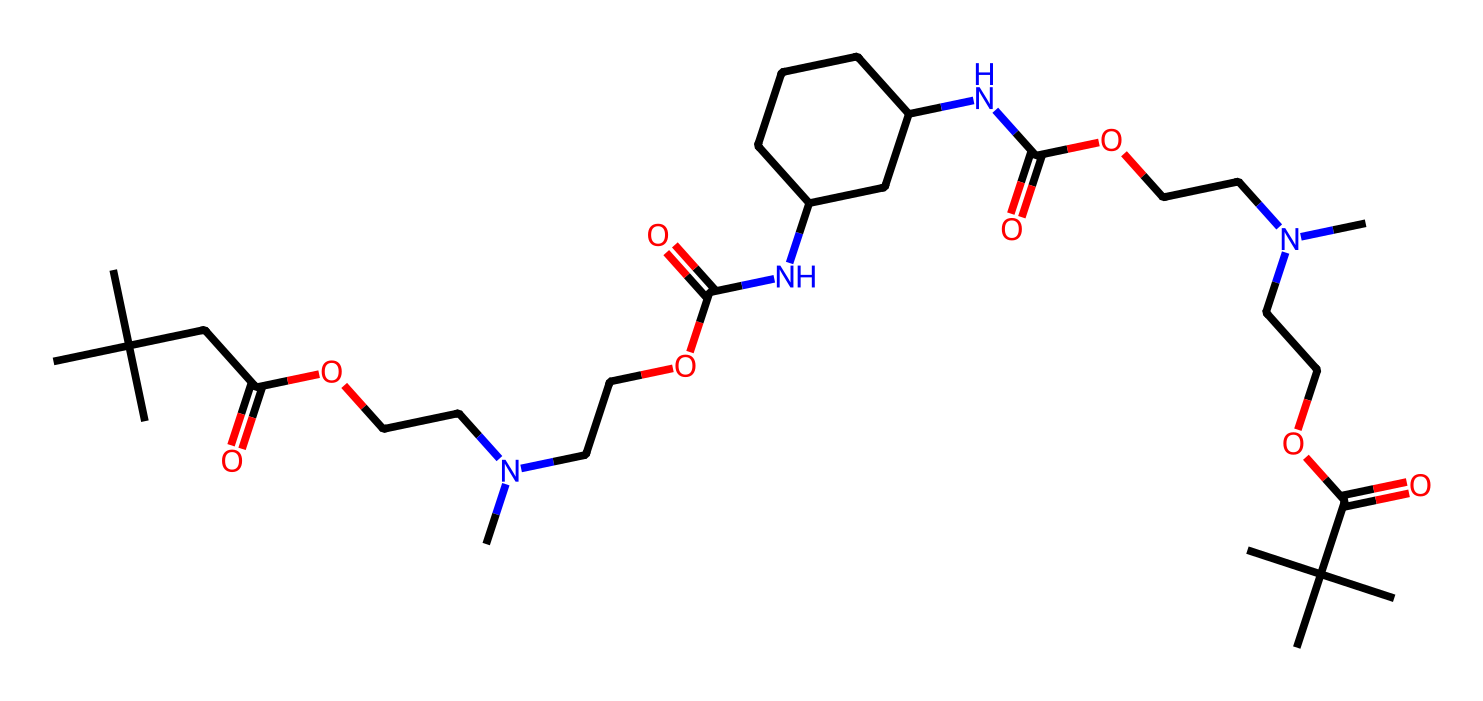What type of polymer is represented by this chemical structure? The structure contains multiple urethane linkages (indicated by the -OC(=O)N-) which confirm its classification as a polyurethane.
Answer: polyurethane How many nitrogen atoms are present in this chemical? By examining the structure, we can count the nitrogen atoms indicated in the formula; there are four distinct nitrogen atoms present.
Answer: four What functional groups are evident in this structure? Analyzing the structure reveals the presence of urethane (-OC(=O)N-), ester (-C(=O)O-), and amine (-N-) functional groups, which play a crucial role in the properties of polyester.
Answer: urethane, ester, amine Does this chemical have a branched or linear structure? The presence of multiple substituents and variations in carbon arrangements in the structure indicates it has a branched structure.
Answer: branched What is the main use of this chemical in the context of travel luggage? Polyurethanes are typically used for their durability and flexibility, making them suitable for the construction of lightweight, resilient luggage materials.
Answer: durability and flexibility How many ester functional groups are in this molecule? The SMILES representation shows two distinct ester groups (-C(=O)O-) in the chemical structure, indicating its multifaceted composition.
Answer: two 